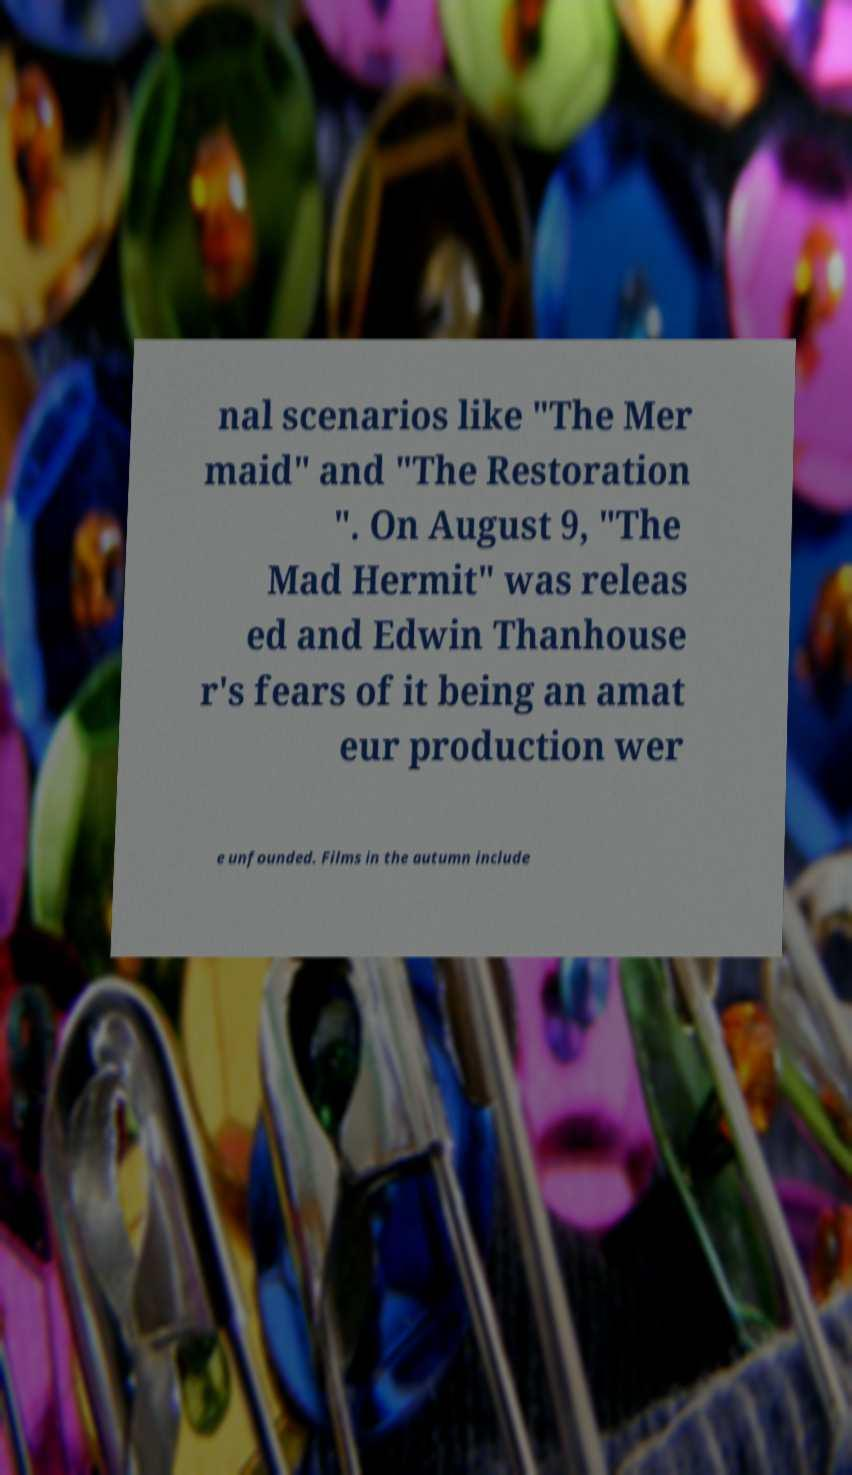For documentation purposes, I need the text within this image transcribed. Could you provide that? nal scenarios like "The Mer maid" and "The Restoration ". On August 9, "The Mad Hermit" was releas ed and Edwin Thanhouse r's fears of it being an amat eur production wer e unfounded. Films in the autumn include 